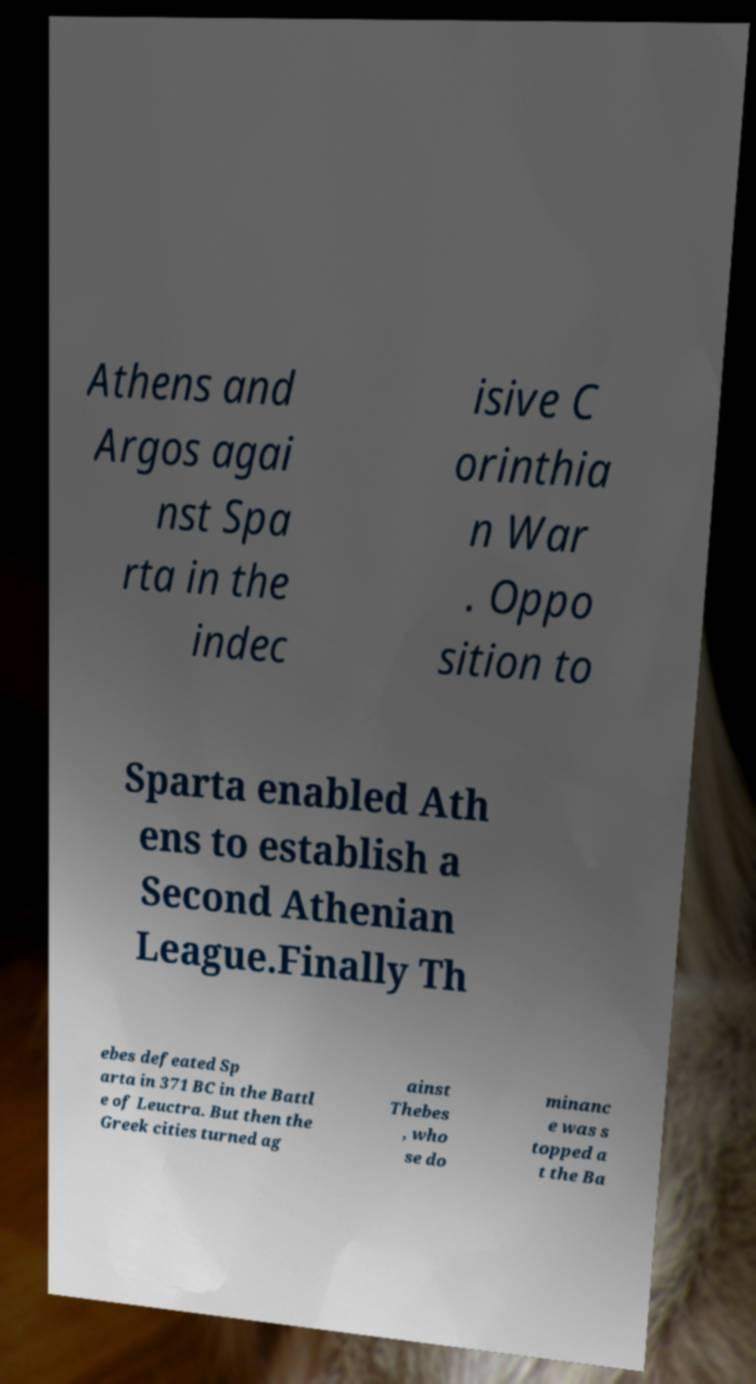Can you accurately transcribe the text from the provided image for me? Athens and Argos agai nst Spa rta in the indec isive C orinthia n War . Oppo sition to Sparta enabled Ath ens to establish a Second Athenian League.Finally Th ebes defeated Sp arta in 371 BC in the Battl e of Leuctra. But then the Greek cities turned ag ainst Thebes , who se do minanc e was s topped a t the Ba 